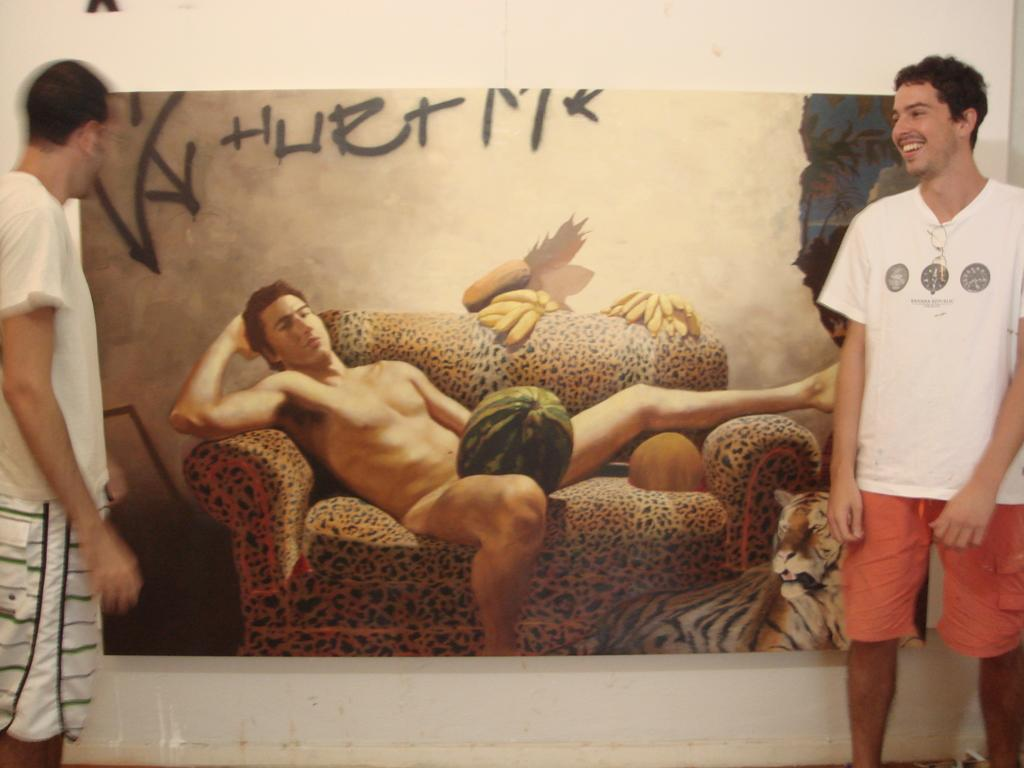How many people are in the image? There are two men in the image. What are the men doing in the image? The men are standing on the ground and smiling. What can be seen in the background of the image? There is a poster in the background of the image. What is depicted on the poster? The poster features a man sitting on a sofa and a tiger. What type of plastic material is being used by the men in the image? There is no plastic material visible in the image; the men are simply standing and smiling. What is the head of the tiger doing in the image? There is no head of a tiger present in the image; the tiger is depicted in its entirety on the poster. 